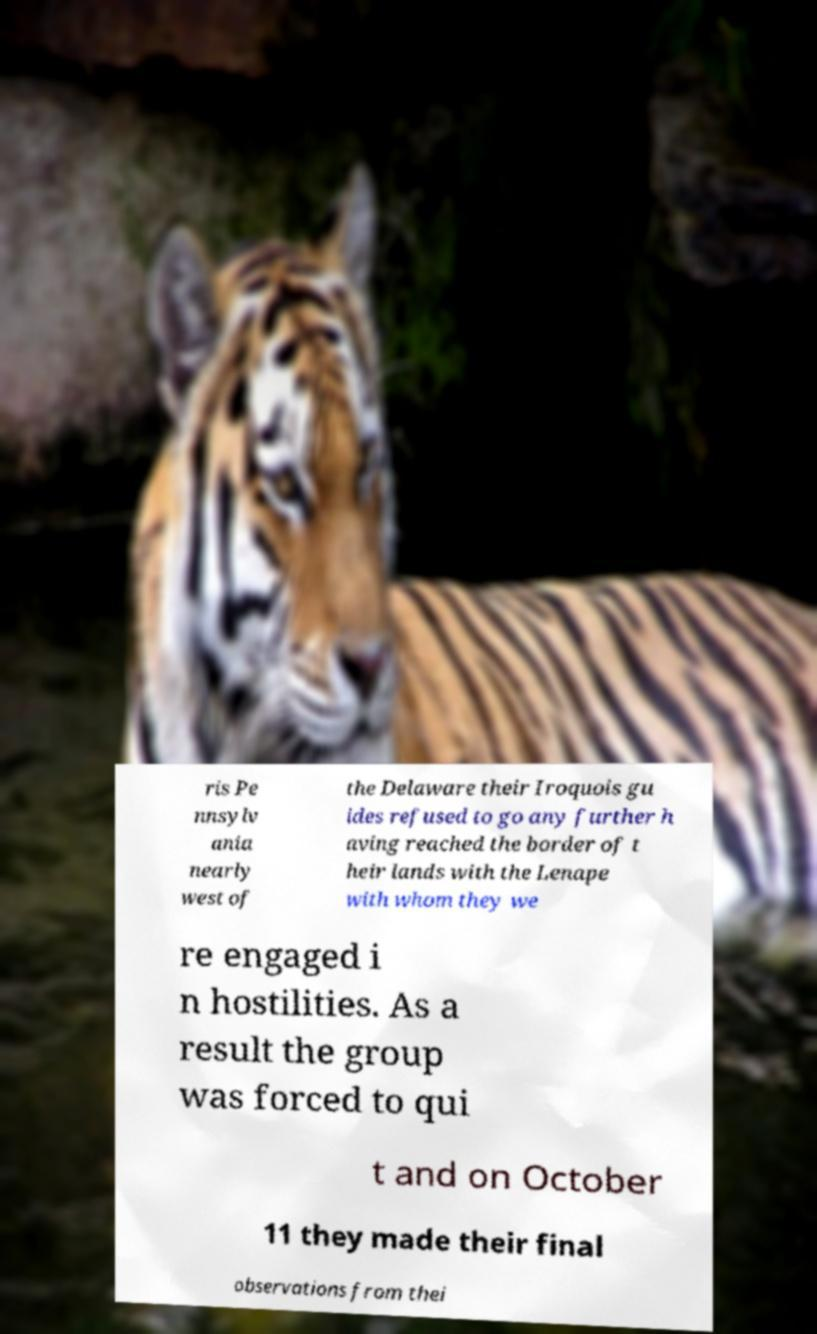Could you extract and type out the text from this image? ris Pe nnsylv ania nearly west of the Delaware their Iroquois gu ides refused to go any further h aving reached the border of t heir lands with the Lenape with whom they we re engaged i n hostilities. As a result the group was forced to qui t and on October 11 they made their final observations from thei 